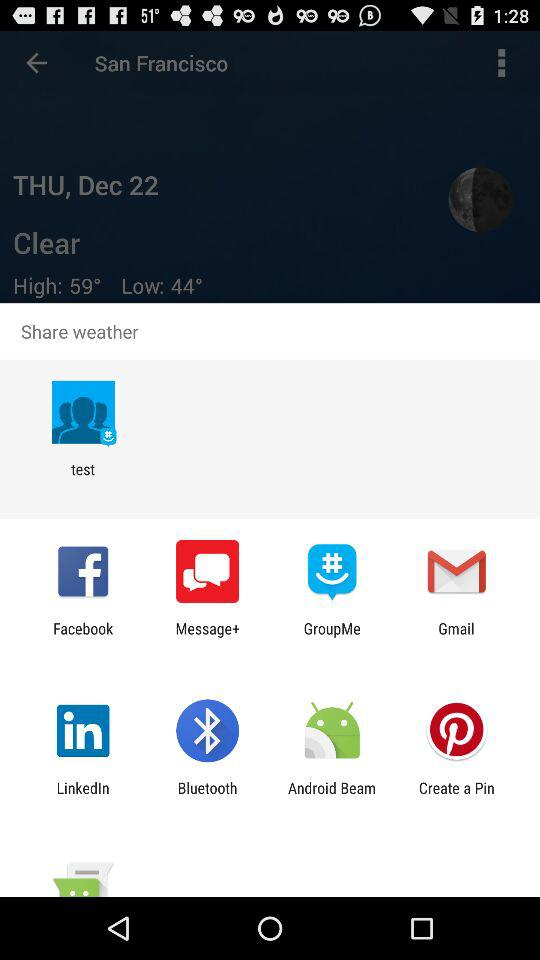Which apps can be used to share the weather? The apps that can be used to share are "test", "Facebook", "Message+", "GroupMe", "Gmail", "LinkedIn", "Bluetooth", "Android Beam" and "Create a Pin". 